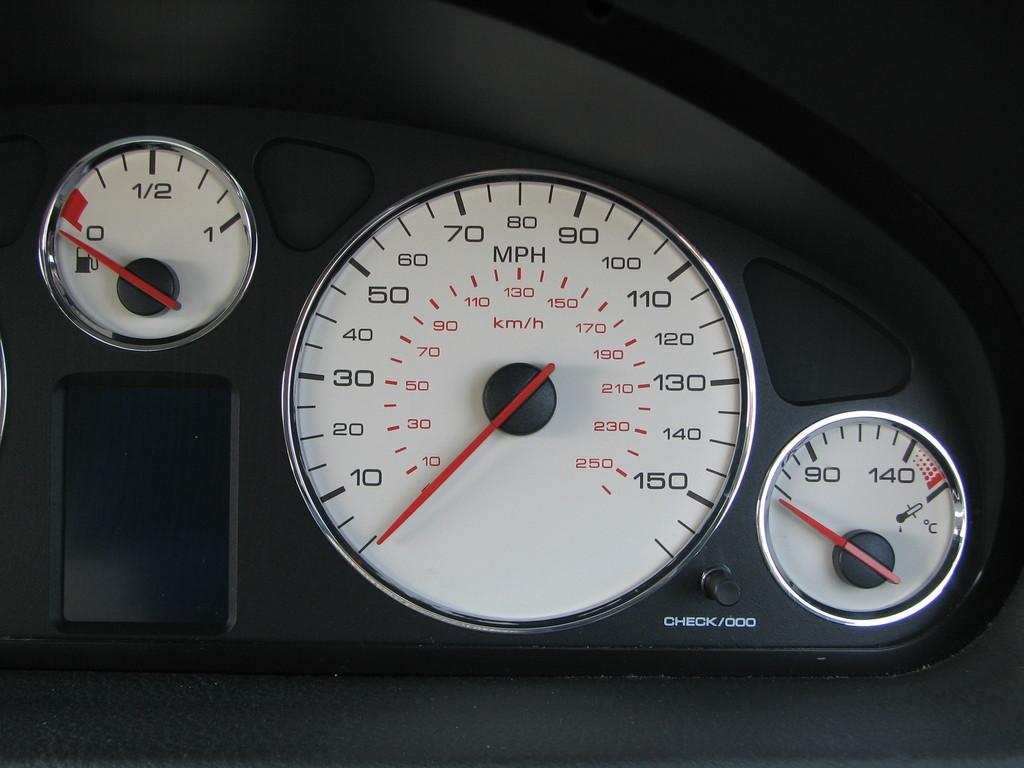Can you describe this image briefly? In this picture I can see vehicles speedometer, fuel tank and temperature gauge. 